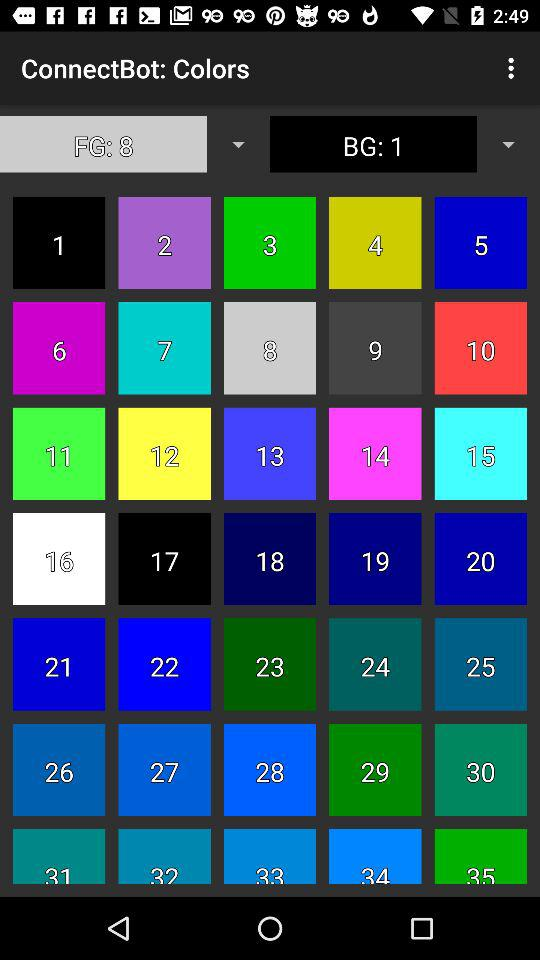Which color number is chosen as the background color? The color number 1 is chosen as the background color. 